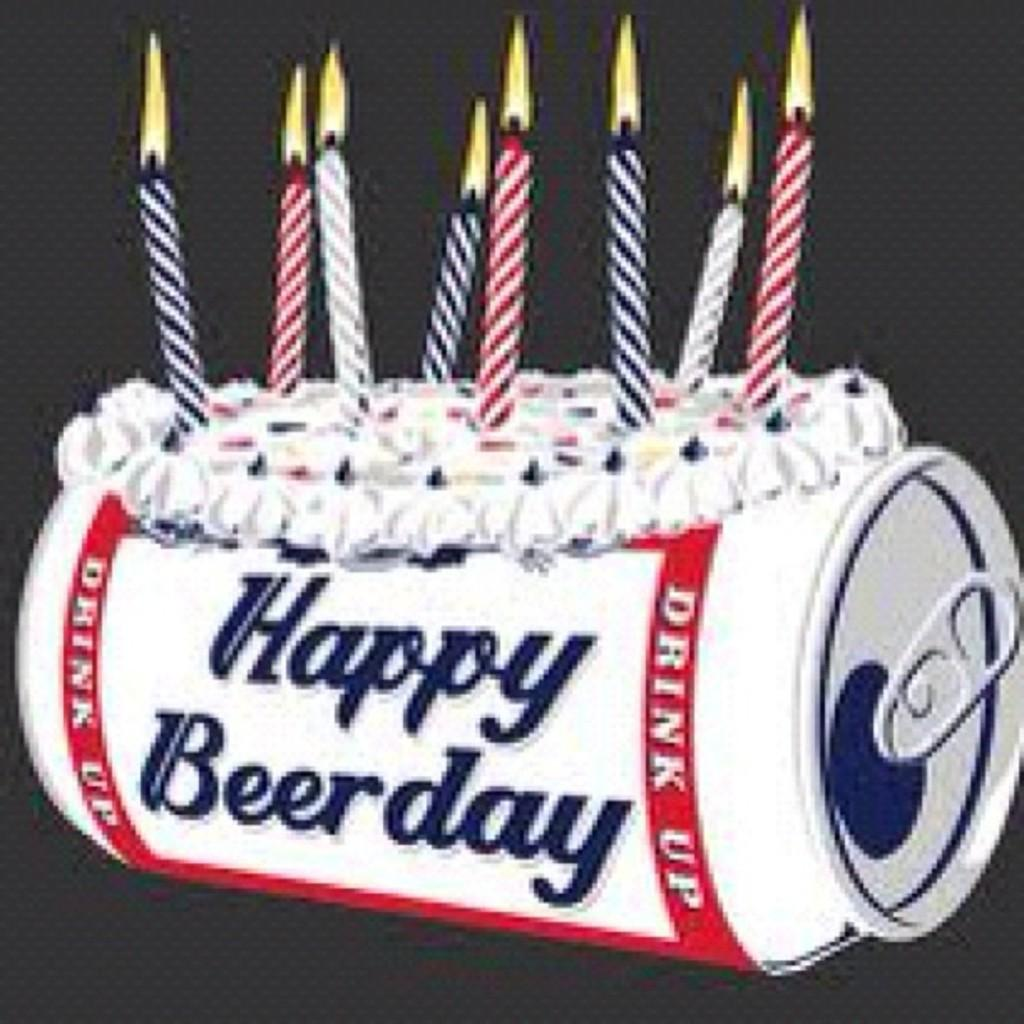What type of image is depicted in the picture? There is a cartoon of a cake in the image. What is placed on top of the cake in the image? There are candles in the image. What other object can be seen in the image? There is a tin in the image. What type of chair is depicted in the image? There is no chair present in the image. What type of jam is spread on the cake in the image? There is no jam or cream present in the image; it is a cartoon of a cake with candles. 